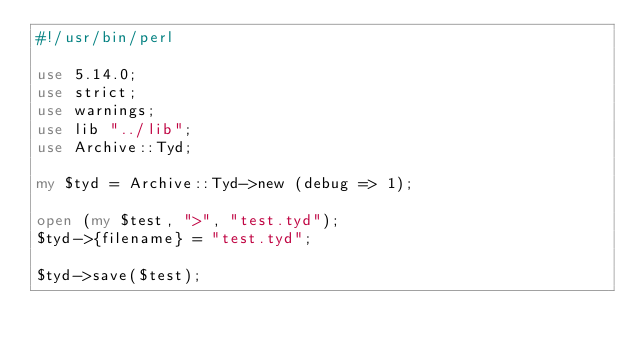Convert code to text. <code><loc_0><loc_0><loc_500><loc_500><_Perl_>#!/usr/bin/perl

use 5.14.0;
use strict;
use warnings;
use lib "../lib";
use Archive::Tyd;

my $tyd = Archive::Tyd->new (debug => 1);

open (my $test, ">", "test.tyd");
$tyd->{filename} = "test.tyd";

$tyd->save($test);
</code> 